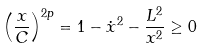Convert formula to latex. <formula><loc_0><loc_0><loc_500><loc_500>\left ( \frac { x } { C } \right ) ^ { 2 p } = 1 - \dot { x } ^ { 2 } - \frac { L ^ { 2 } } { x ^ { 2 } } \geq 0</formula> 